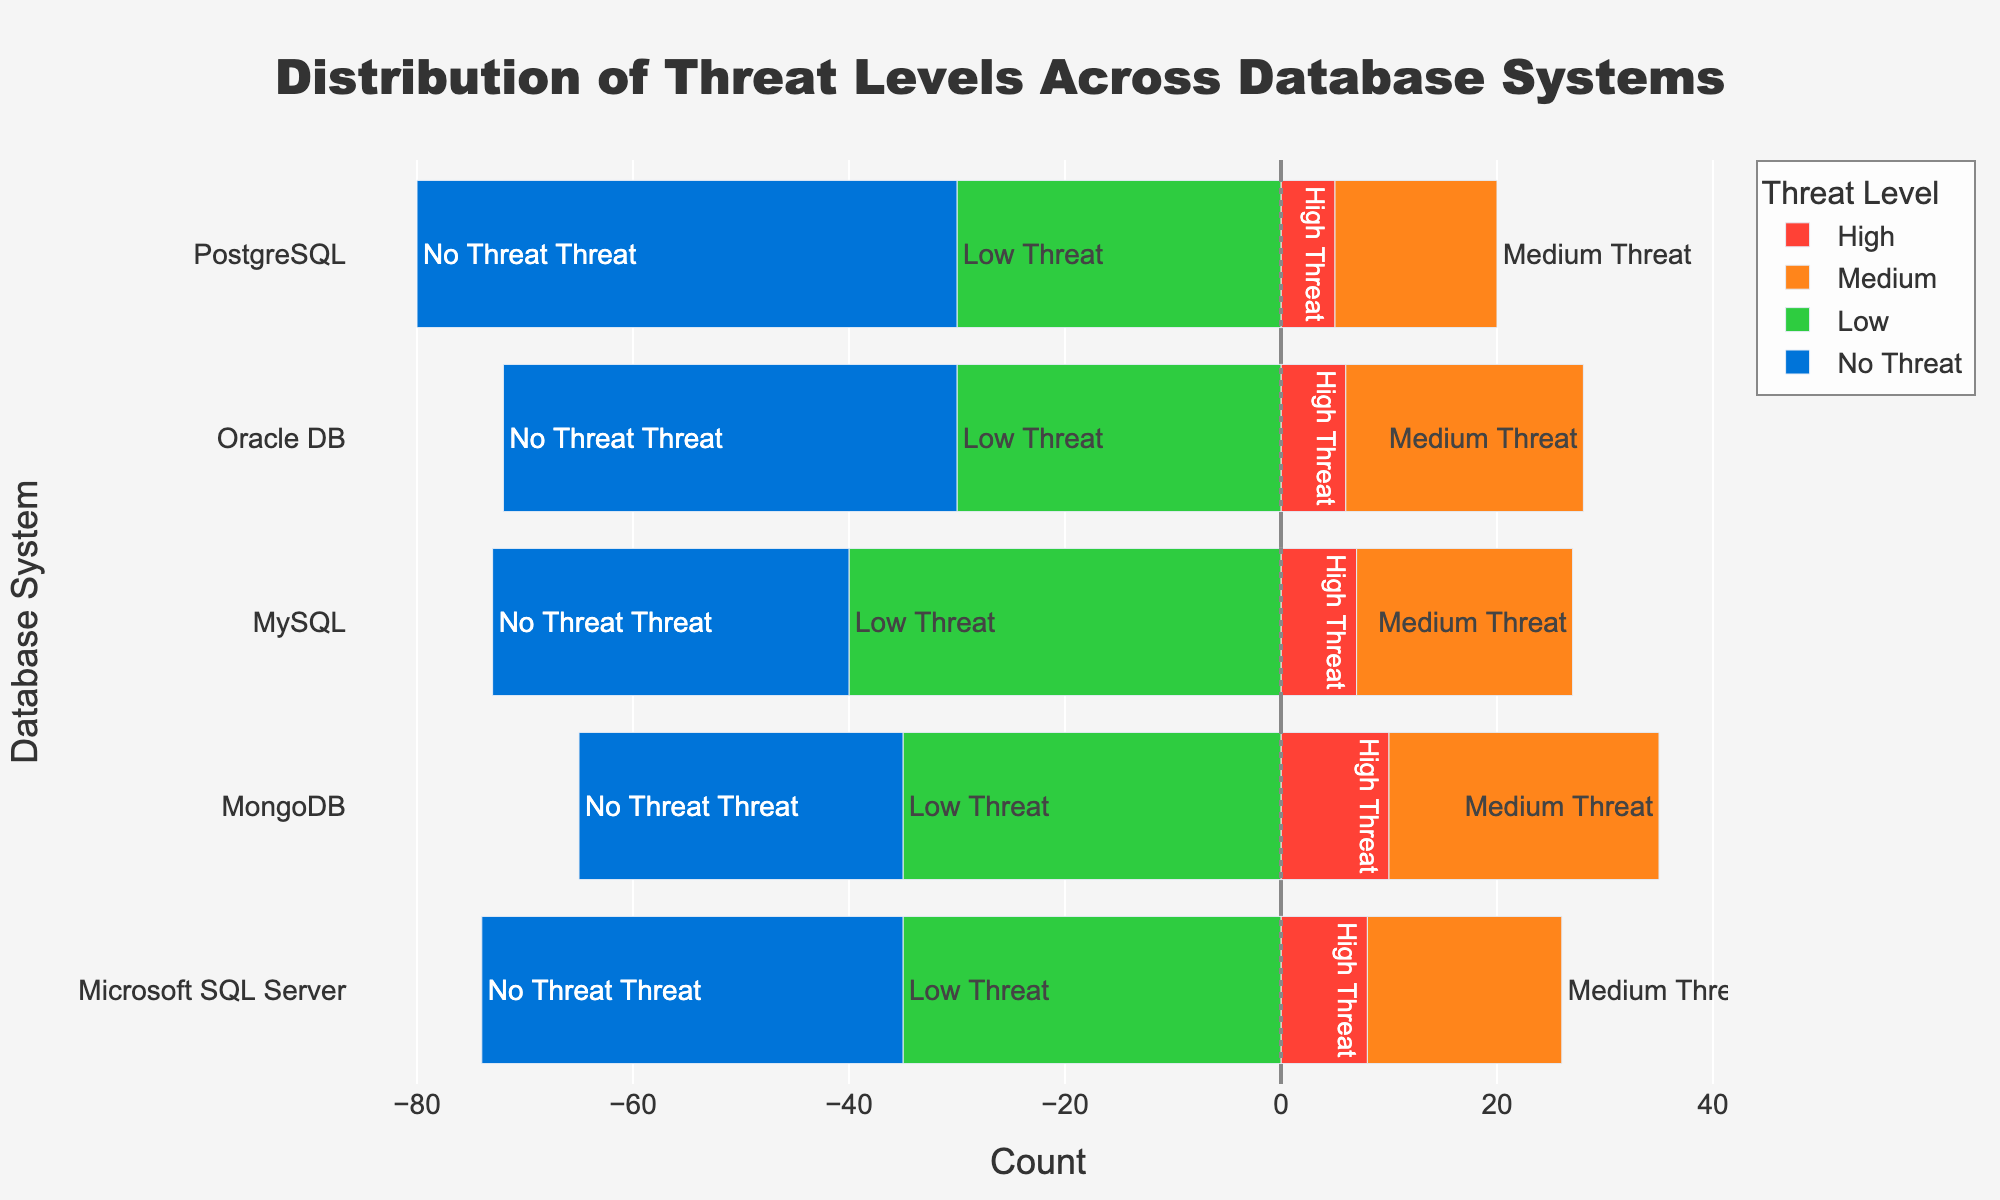Which database system has the highest count of 'High' threat levels? By examining the bar lengths, we observe that MongoDB has the longest bar in the 'High' threat level section with a count of 10.
Answer: MongoDB Which database systems have 'No Threat' counts greater than the 'Low' threat counts? By comparing the lengths of the 'No Threat' and 'Low' threat bars, we see that PostgreSQL and Oracle DB have longer 'No Threat' bars than 'Low' threat bars.
Answer: PostgreSQL, Oracle DB What is the total count of 'Medium' threat levels across all database systems? Adding the counts for the 'Medium' threat level for all databases: 15 (PostgreSQL) + 20 (MySQL) + 18 (Microsoft SQL Server) + 22 (Oracle DB) + 25 (MongoDB) = 100.
Answer: 100 How does the 'Low' threat count for Microsoft SQL Server compare to the 'Medium' threat count for Oracle DB? The 'Low' threat count for Microsoft SQL Server is 35, and the 'Medium' threat count for Oracle DB is 22. 35 is greater than 22.
Answer: Greater Which database system has the smallest difference between the 'High' threat and 'No Threat' counts? By calculating the difference between 'High' threat and 'No Threat' for each database: PostgreSQL (50-5=45), MySQL (33-7=26), Microsoft SQL Server (39-8=31), Oracle DB (42-6=36), MongoDB (30-10=20). MongoDB has the smallest difference of 20.
Answer: MongoDB In which database system does the 'High' threat level make up less than 10% of the total threats (High, Medium, Low, No Threat)? Calculate 10% of the total for each system and check if 'High' threat is smaller: PostgreSQL (5/100=5%), MySQL (7/100=7%), Microsoft SQL Server (8/100=8%), Oracle DB (6/100=6%), MongoDB (10/100=10%). It's true for PostgreSQL, MySQL, Microsoft SQL Server, Oracle DB.
Answer: PostgreSQL, MySQL, Microsoft SQL Server, Oracle DB 